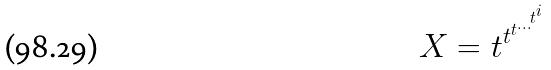Convert formula to latex. <formula><loc_0><loc_0><loc_500><loc_500>X = t ^ { t ^ { t ^ { \dots ^ { t ^ { i } } } } }</formula> 